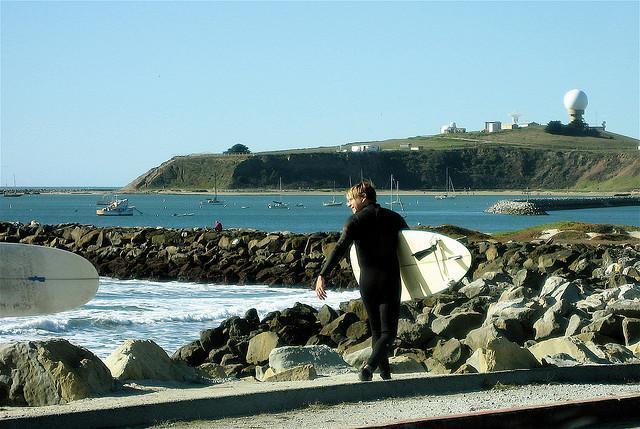How many surfboards can you see?
Give a very brief answer. 2. How many standing cows are there in the image ?
Give a very brief answer. 0. 